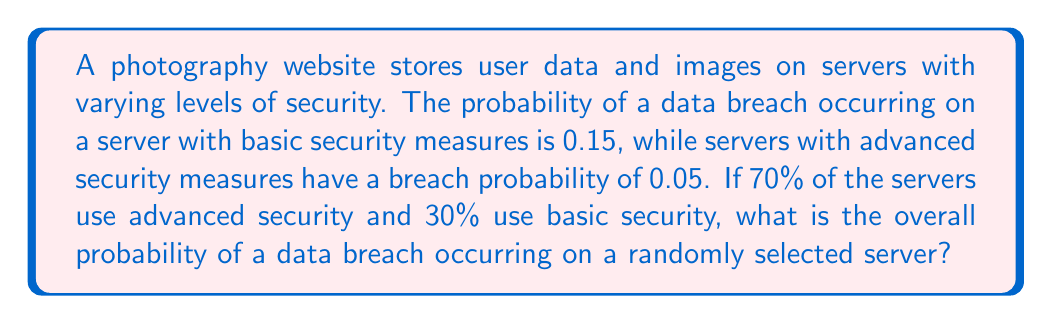What is the answer to this math problem? To solve this problem, we'll use the law of total probability. Let's break it down step by step:

1. Define events:
   A: Advanced security server
   B: Basic security server
   D: Data breach occurs

2. Given probabilities:
   P(A) = 0.70 (70% of servers use advanced security)
   P(B) = 0.30 (30% of servers use basic security)
   P(D|A) = 0.05 (probability of breach on advanced security server)
   P(D|B) = 0.15 (probability of breach on basic security server)

3. Apply the law of total probability:
   $$P(D) = P(D|A) \cdot P(A) + P(D|B) \cdot P(B)$$

4. Substitute the values:
   $$P(D) = 0.05 \cdot 0.70 + 0.15 \cdot 0.30$$

5. Calculate:
   $$P(D) = 0.035 + 0.045 = 0.08$$

Therefore, the overall probability of a data breach occurring on a randomly selected server is 0.08 or 8%.
Answer: 0.08 or 8% 